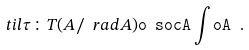<formula> <loc_0><loc_0><loc_500><loc_500>\ t i l { \tau } \colon T ( A / \ r a d A ) \tt o \ s o c A \int o A \ .</formula> 